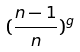Convert formula to latex. <formula><loc_0><loc_0><loc_500><loc_500>( \frac { n - 1 } { n } ) ^ { g }</formula> 